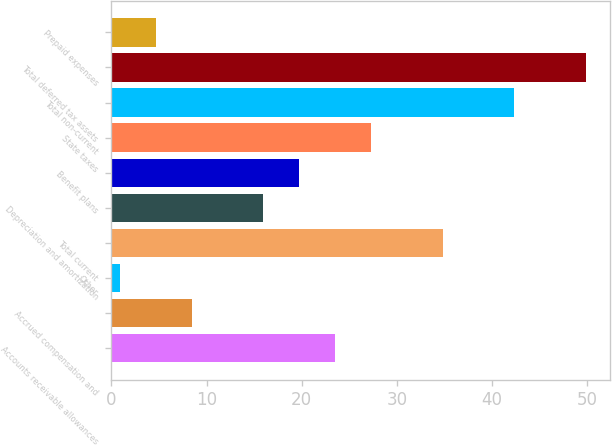Convert chart. <chart><loc_0><loc_0><loc_500><loc_500><bar_chart><fcel>Accounts receivable allowances<fcel>Accrued compensation and<fcel>Other<fcel>Total current<fcel>Depreciation and amortization<fcel>Benefit plans<fcel>State taxes<fcel>Total non-current<fcel>Total deferred tax assets<fcel>Prepaid expenses<nl><fcel>23.52<fcel>8.44<fcel>0.9<fcel>34.83<fcel>15.98<fcel>19.75<fcel>27.29<fcel>42.37<fcel>49.91<fcel>4.67<nl></chart> 